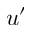Convert formula to latex. <formula><loc_0><loc_0><loc_500><loc_500>u ^ { \prime }</formula> 